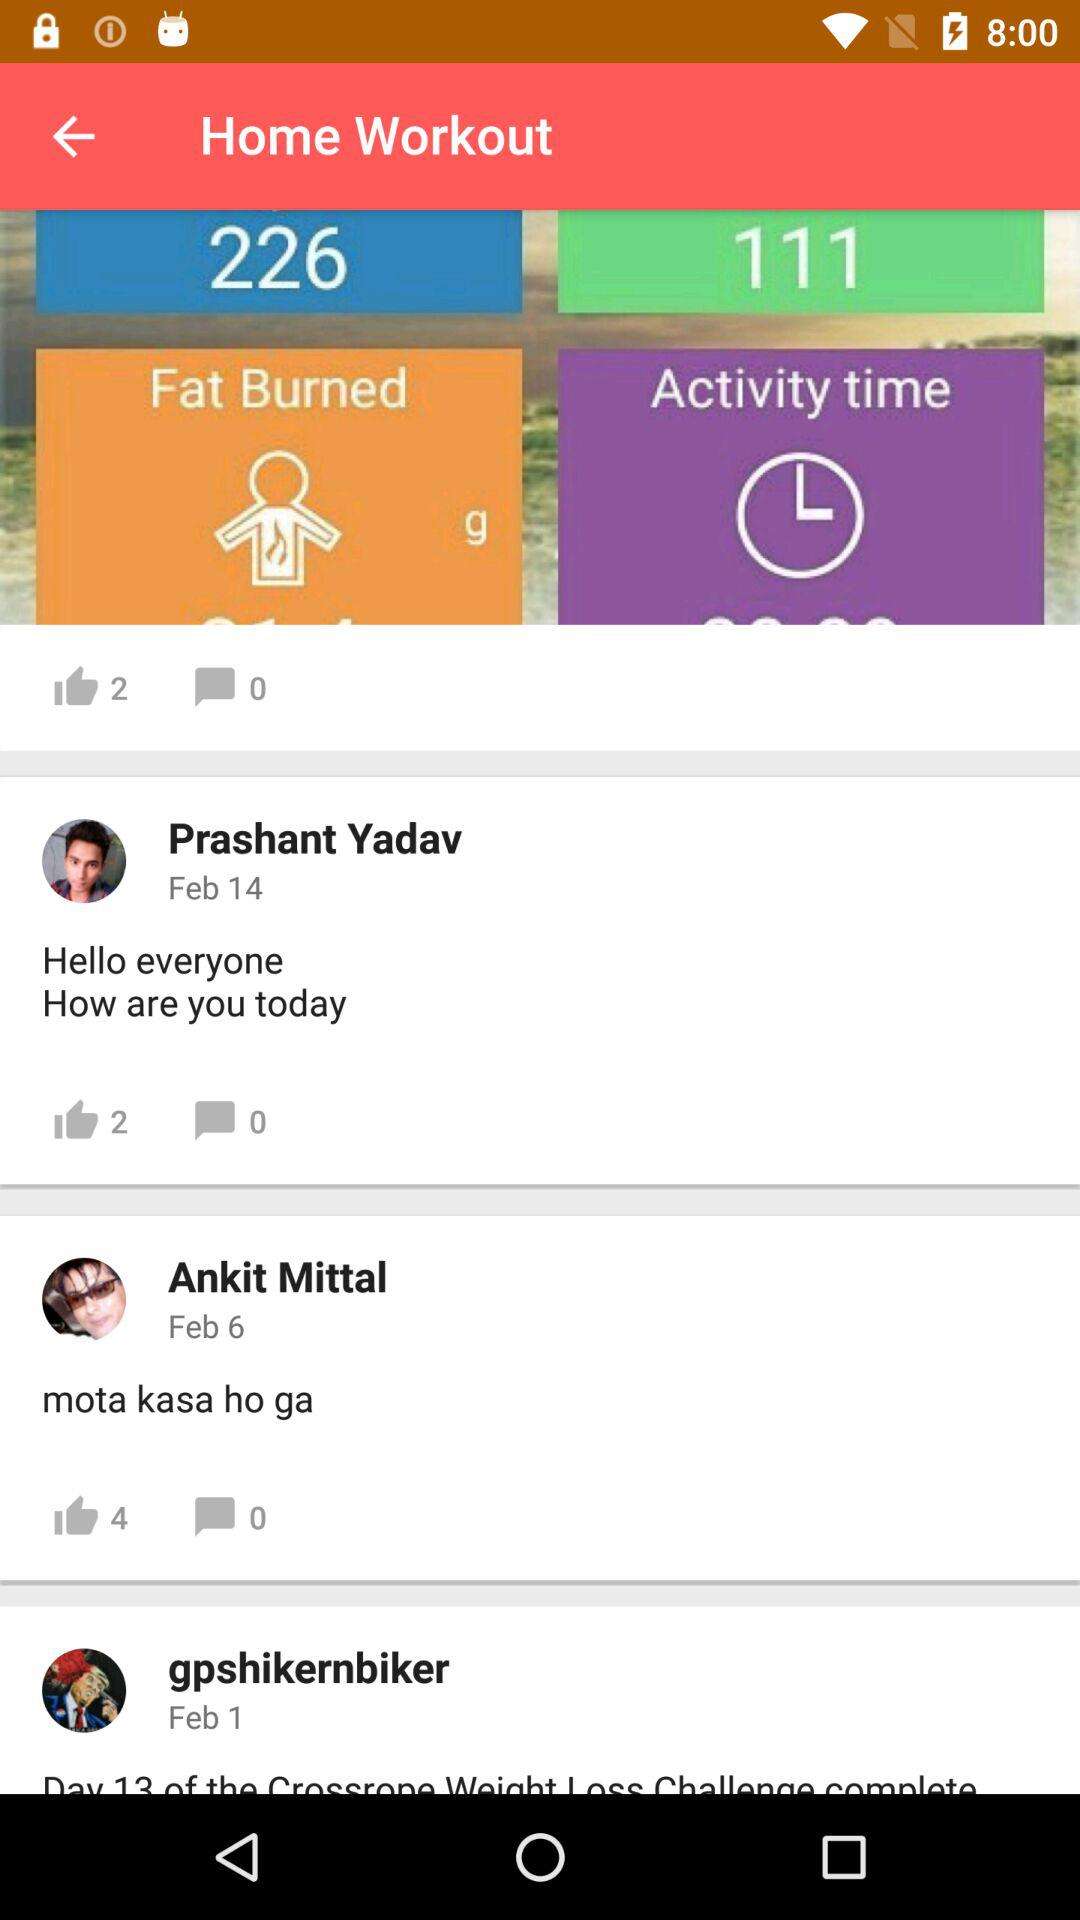Which user commented on February 1? On February 1, "gpshikernbiker" commented. 